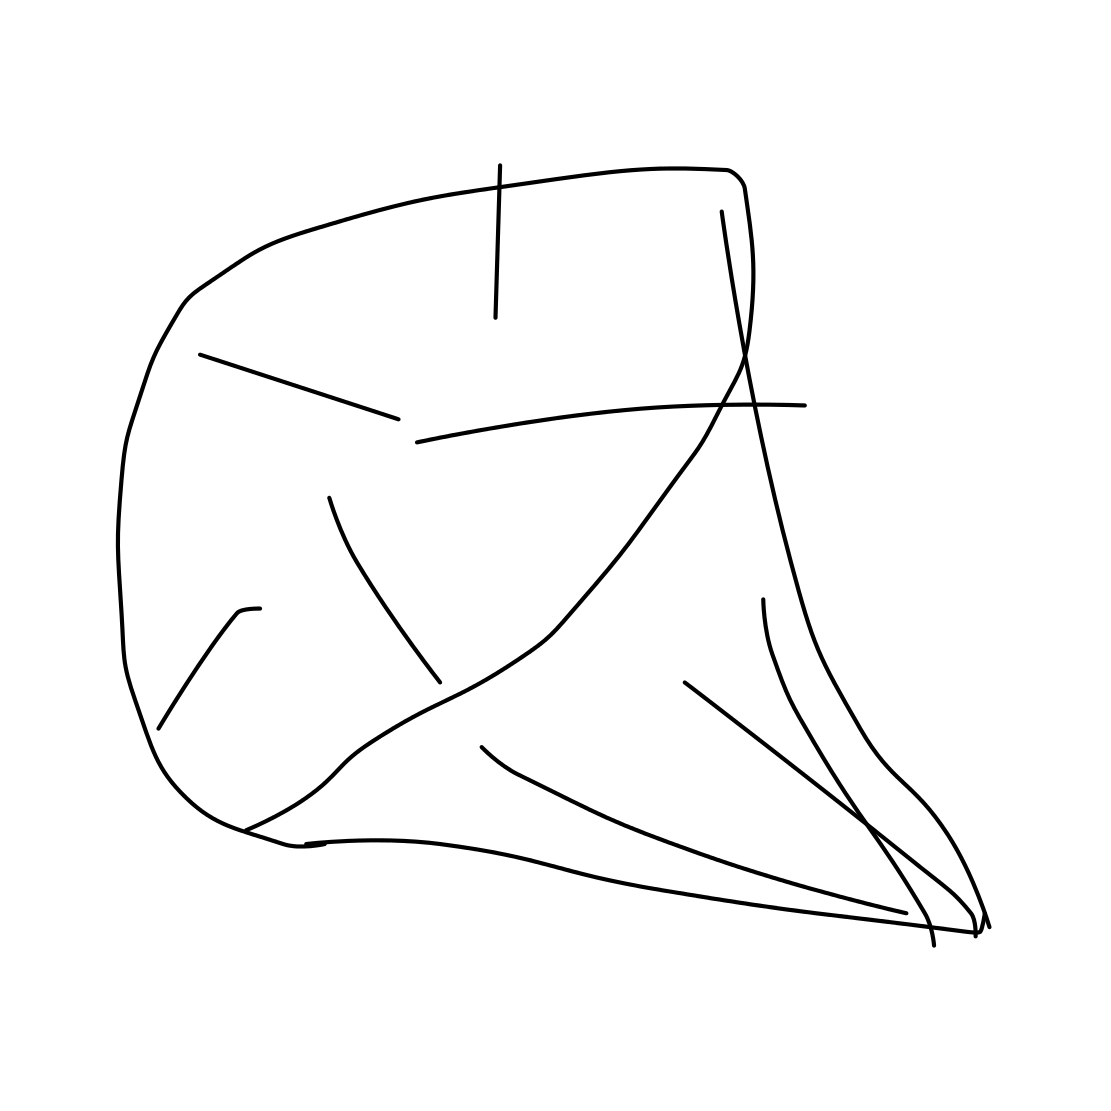Is this a diamond in the image? The image does not depict a real diamond. It appears to be a simple line drawing, possibly representing an abstract or stylized version of a diamond, but it lacks the complexity and precision typically associated with the faceted structure of a genuine diamond gemstone. 